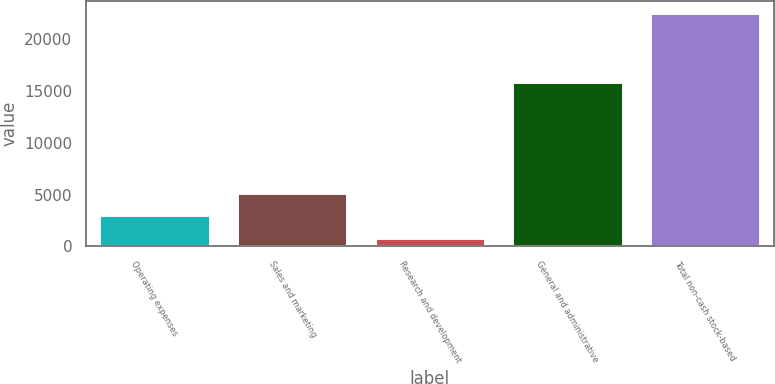Convert chart to OTSL. <chart><loc_0><loc_0><loc_500><loc_500><bar_chart><fcel>Operating expenses<fcel>Sales and marketing<fcel>Research and development<fcel>General and administrative<fcel>Total non-cash stock-based<nl><fcel>3007<fcel>5178<fcel>836<fcel>15837<fcel>22546<nl></chart> 